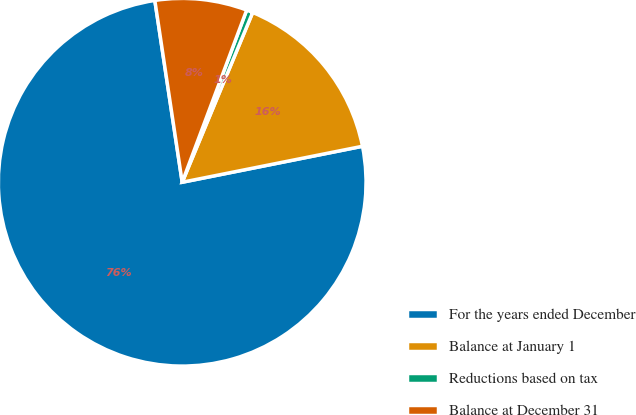Convert chart. <chart><loc_0><loc_0><loc_500><loc_500><pie_chart><fcel>For the years ended December<fcel>Balance at January 1<fcel>Reductions based on tax<fcel>Balance at December 31<nl><fcel>75.75%<fcel>15.6%<fcel>0.56%<fcel>8.08%<nl></chart> 